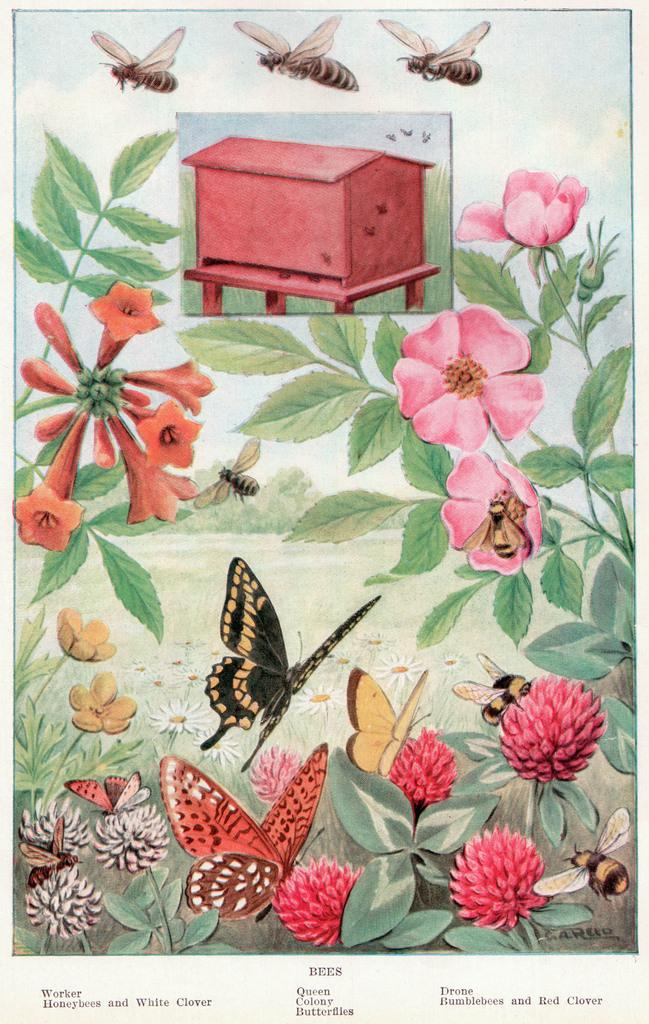What type of visual is the image? The image is a poster. What creatures are depicted on the poster? Flies and butterflies are depicted on the poster. What other elements are present on the poster? Flowers and plants are depicted on the poster. Is there any text on the poster? Yes, there is text written at the bottom of the poster. What type of toys are depicted on the poster? There are no toys depicted on the poster; it features flies, butterflies, flowers, and plants. What time of day is it in the image? The image is a poster and does not depict a specific time of day, so it cannot be determined from the image. 